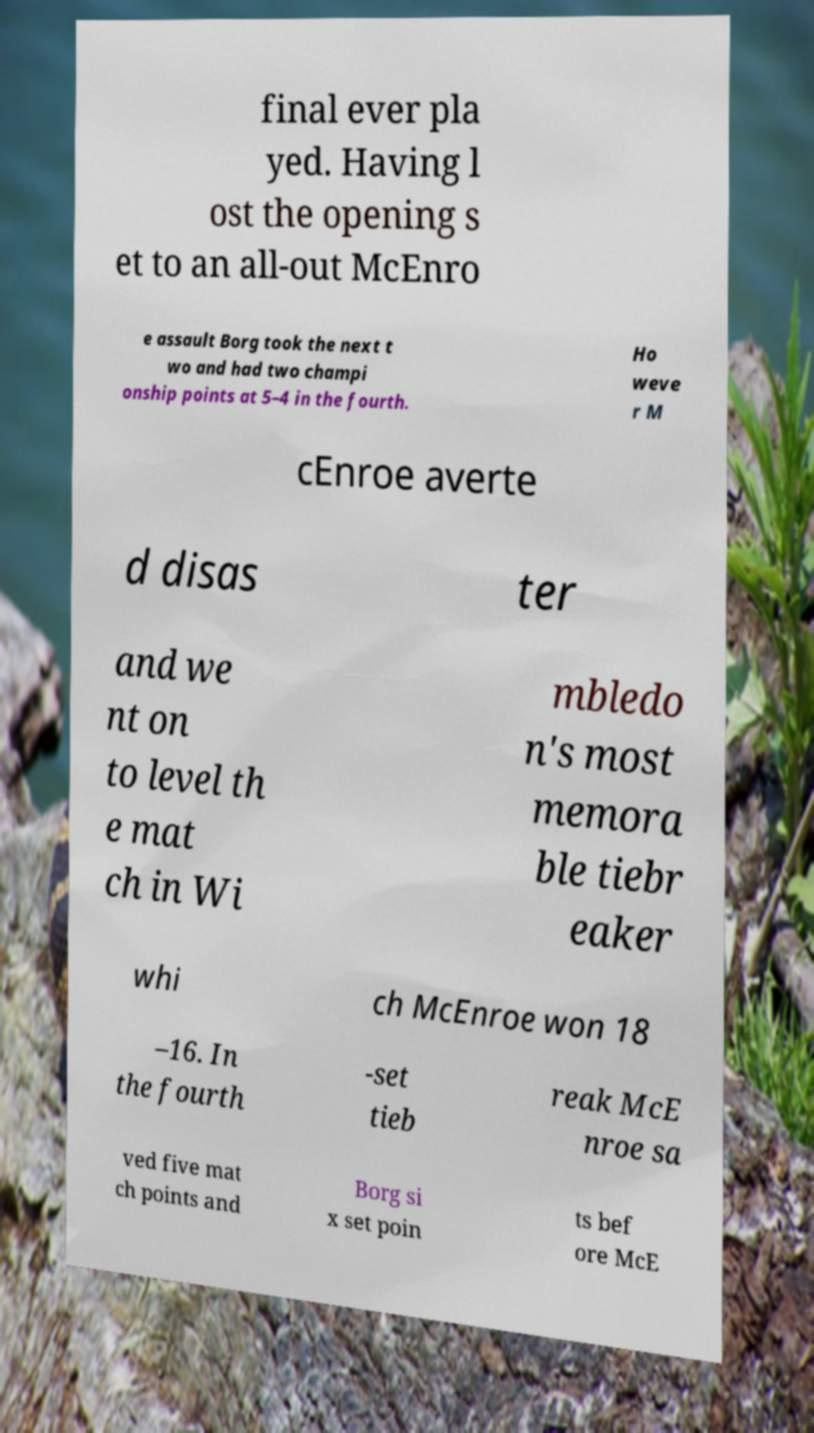Please read and relay the text visible in this image. What does it say? final ever pla yed. Having l ost the opening s et to an all-out McEnro e assault Borg took the next t wo and had two champi onship points at 5–4 in the fourth. Ho weve r M cEnroe averte d disas ter and we nt on to level th e mat ch in Wi mbledo n's most memora ble tiebr eaker whi ch McEnroe won 18 –16. In the fourth -set tieb reak McE nroe sa ved five mat ch points and Borg si x set poin ts bef ore McE 